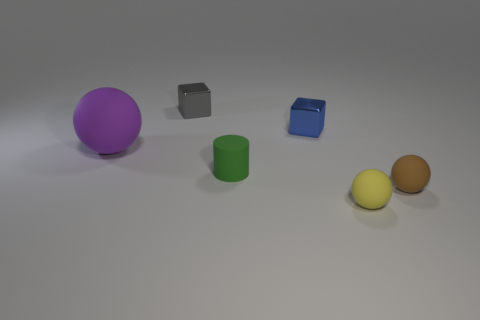There is a cube right of the small gray cube; are there any metal things that are on the left side of it?
Provide a succinct answer. Yes. What number of yellow objects are small balls or matte cylinders?
Keep it short and to the point. 1. What is the color of the large matte ball?
Your answer should be very brief. Purple. There is another yellow sphere that is made of the same material as the big sphere; what is its size?
Provide a short and direct response. Small. What number of tiny yellow rubber things are the same shape as the brown object?
Ensure brevity in your answer.  1. Is there any other thing that has the same size as the brown rubber ball?
Give a very brief answer. Yes. What is the size of the rubber object right of the ball that is in front of the brown matte sphere?
Make the answer very short. Small. There is a yellow ball that is the same size as the blue metal object; what is it made of?
Offer a terse response. Rubber. Are there any tiny blue blocks made of the same material as the blue object?
Provide a succinct answer. No. What color is the shiny cube that is in front of the metallic cube that is to the left of the shiny block in front of the small gray metallic cube?
Offer a very short reply. Blue. 